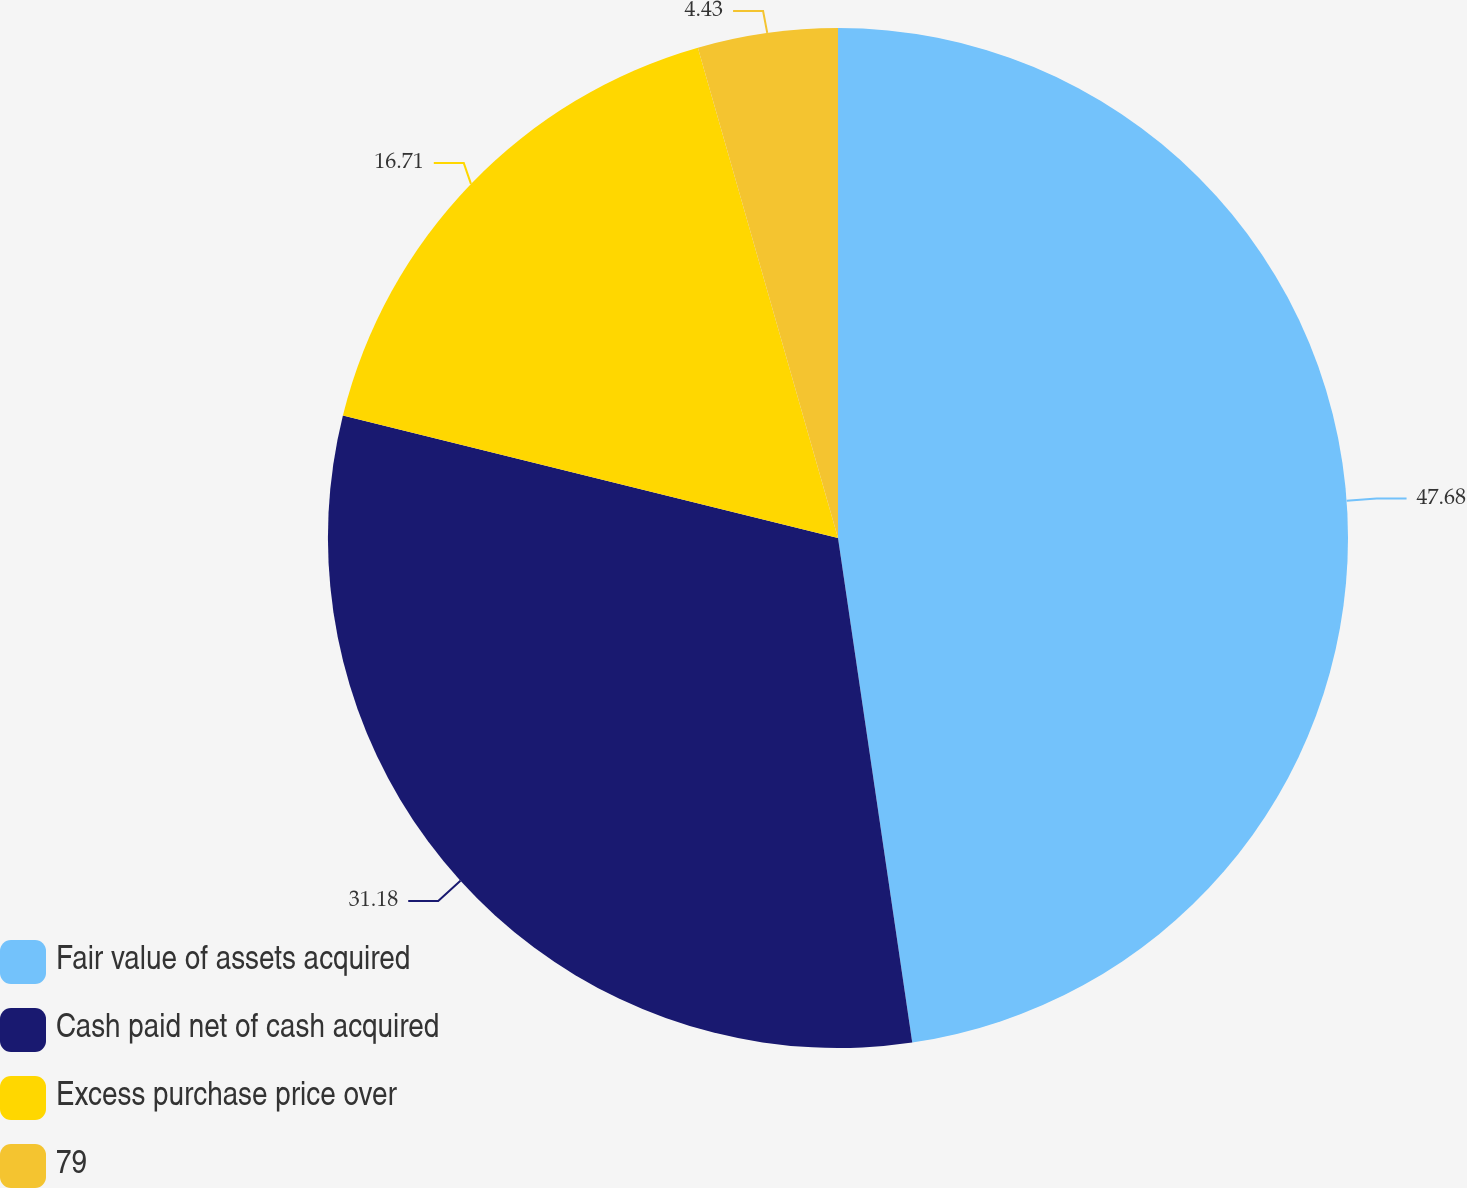<chart> <loc_0><loc_0><loc_500><loc_500><pie_chart><fcel>Fair value of assets acquired<fcel>Cash paid net of cash acquired<fcel>Excess purchase price over<fcel>79<nl><fcel>47.67%<fcel>31.18%<fcel>16.71%<fcel>4.43%<nl></chart> 